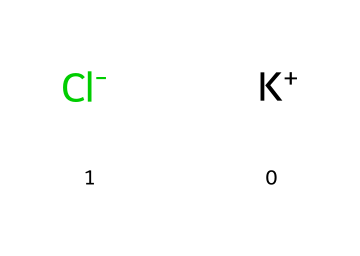What is the chemical formula for potassium chloride? The SMILES representation shows the presence of potassium (K) and chloride (Cl) ions, indicating that the chemical formula is composed of one potassium and one chloride atom, hence KCl.
Answer: KCl How many atoms are present in the structure? The SMILES notation consists of two ions: one potassium ion and one chloride ion, totaling two atoms in the chemical structure.
Answer: 2 What type of bond exists between potassium and chloride? The interaction between potassium and chloride is an ionic bond, as potassium donates an electron to chloride, forming K+ and Cl- ions.
Answer: ionic What charge does potassium have in this compound? The SMILES structure specifies that potassium is represented as K+, indicating that it possesses a positive charge.
Answer: positive What property of potassium chloride aids in its use as an anti-icing solution? The ionic nature of potassium chloride allows it to dissociate in water and lower the freezing point, which is effective in anti-icing applications.
Answer: lowers freezing point How does the presence of chloride ions affect the conductivity of this electrolyte? The chloride ions (Cl-) increase the ion concentration in solution, enhancing the electrical conductivity of potassium chloride when dissolved in water.
Answer: increases conductivity What role does the ratio of potassium to chloride play in the chemical structure? The 1:1 ratio between potassium and chloride ions ensures charge neutrality, which is essential for the stability of the ionic compound KCl.
Answer: charge neutrality 